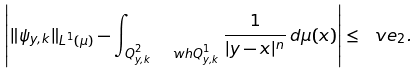<formula> <loc_0><loc_0><loc_500><loc_500>\left | \| \psi _ { y , k } \| _ { L ^ { 1 } ( \mu ) } - \int _ { Q _ { y , k } ^ { 2 } \ \ w h { Q } _ { y , k } ^ { 1 } } \frac { 1 } { | y - x | ^ { n } } \, d \mu ( x ) \right | \leq \ v e _ { 2 } .</formula> 